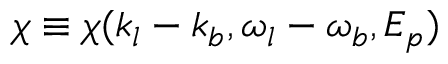<formula> <loc_0><loc_0><loc_500><loc_500>\chi \equiv \chi ( k _ { l } - k _ { b } , \omega _ { l } - \omega _ { b } , E _ { p } )</formula> 